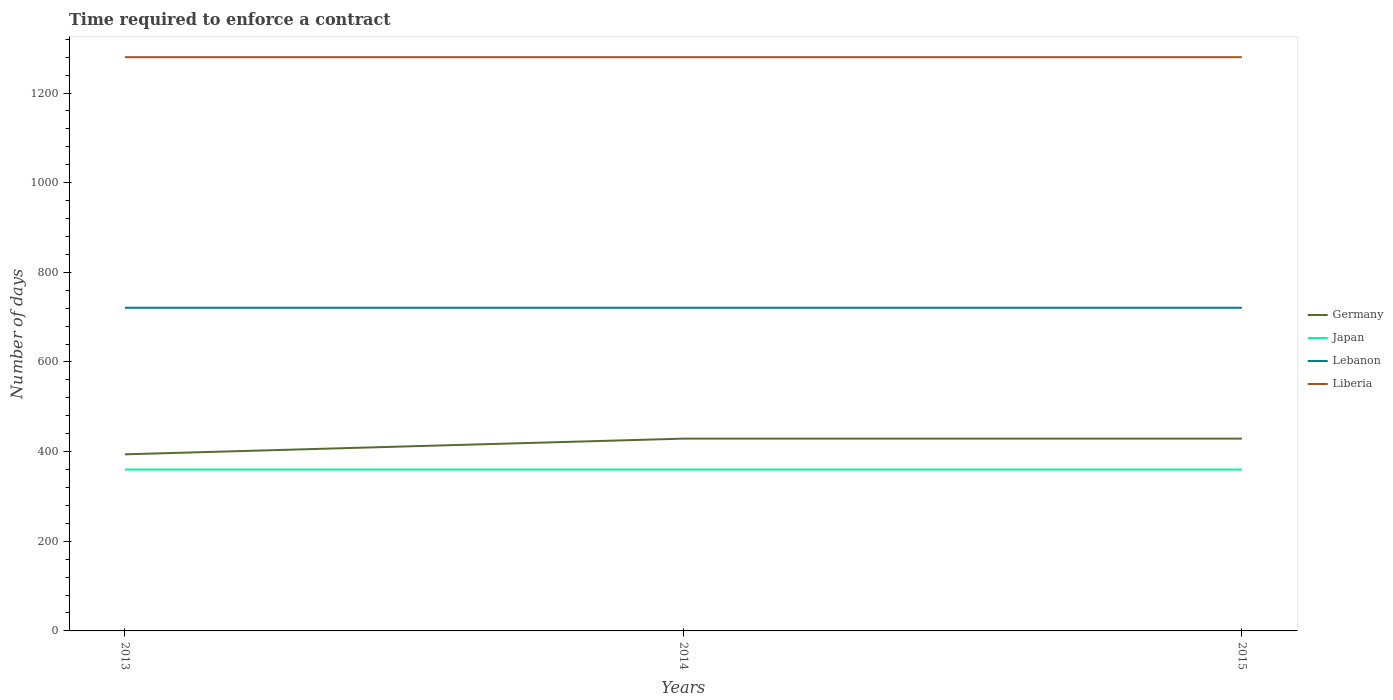How many different coloured lines are there?
Provide a short and direct response. 4. Does the line corresponding to Japan intersect with the line corresponding to Liberia?
Ensure brevity in your answer.  No. Across all years, what is the maximum number of days required to enforce a contract in Lebanon?
Provide a succinct answer. 721. What is the total number of days required to enforce a contract in Japan in the graph?
Give a very brief answer. 0. What is the difference between the highest and the second highest number of days required to enforce a contract in Lebanon?
Provide a short and direct response. 0. Is the number of days required to enforce a contract in Liberia strictly greater than the number of days required to enforce a contract in Germany over the years?
Provide a succinct answer. No. What is the difference between two consecutive major ticks on the Y-axis?
Your response must be concise. 200. How many legend labels are there?
Your answer should be compact. 4. What is the title of the graph?
Your response must be concise. Time required to enforce a contract. What is the label or title of the X-axis?
Ensure brevity in your answer.  Years. What is the label or title of the Y-axis?
Your answer should be compact. Number of days. What is the Number of days in Germany in 2013?
Your response must be concise. 394. What is the Number of days of Japan in 2013?
Offer a terse response. 360. What is the Number of days of Lebanon in 2013?
Make the answer very short. 721. What is the Number of days of Liberia in 2013?
Keep it short and to the point. 1280. What is the Number of days of Germany in 2014?
Your answer should be compact. 429. What is the Number of days in Japan in 2014?
Offer a very short reply. 360. What is the Number of days in Lebanon in 2014?
Your response must be concise. 721. What is the Number of days of Liberia in 2014?
Make the answer very short. 1280. What is the Number of days of Germany in 2015?
Offer a terse response. 429. What is the Number of days of Japan in 2015?
Provide a short and direct response. 360. What is the Number of days of Lebanon in 2015?
Your answer should be very brief. 721. What is the Number of days in Liberia in 2015?
Your response must be concise. 1280. Across all years, what is the maximum Number of days in Germany?
Make the answer very short. 429. Across all years, what is the maximum Number of days of Japan?
Your response must be concise. 360. Across all years, what is the maximum Number of days in Lebanon?
Offer a terse response. 721. Across all years, what is the maximum Number of days in Liberia?
Provide a short and direct response. 1280. Across all years, what is the minimum Number of days in Germany?
Provide a succinct answer. 394. Across all years, what is the minimum Number of days in Japan?
Your answer should be very brief. 360. Across all years, what is the minimum Number of days of Lebanon?
Provide a succinct answer. 721. Across all years, what is the minimum Number of days in Liberia?
Your response must be concise. 1280. What is the total Number of days of Germany in the graph?
Keep it short and to the point. 1252. What is the total Number of days in Japan in the graph?
Make the answer very short. 1080. What is the total Number of days in Lebanon in the graph?
Your response must be concise. 2163. What is the total Number of days in Liberia in the graph?
Offer a very short reply. 3840. What is the difference between the Number of days in Germany in 2013 and that in 2014?
Offer a terse response. -35. What is the difference between the Number of days in Lebanon in 2013 and that in 2014?
Your answer should be very brief. 0. What is the difference between the Number of days in Liberia in 2013 and that in 2014?
Offer a very short reply. 0. What is the difference between the Number of days of Germany in 2013 and that in 2015?
Offer a very short reply. -35. What is the difference between the Number of days of Germany in 2014 and that in 2015?
Make the answer very short. 0. What is the difference between the Number of days of Japan in 2014 and that in 2015?
Your answer should be compact. 0. What is the difference between the Number of days of Liberia in 2014 and that in 2015?
Provide a short and direct response. 0. What is the difference between the Number of days of Germany in 2013 and the Number of days of Lebanon in 2014?
Your response must be concise. -327. What is the difference between the Number of days of Germany in 2013 and the Number of days of Liberia in 2014?
Your answer should be very brief. -886. What is the difference between the Number of days of Japan in 2013 and the Number of days of Lebanon in 2014?
Give a very brief answer. -361. What is the difference between the Number of days in Japan in 2013 and the Number of days in Liberia in 2014?
Offer a very short reply. -920. What is the difference between the Number of days of Lebanon in 2013 and the Number of days of Liberia in 2014?
Ensure brevity in your answer.  -559. What is the difference between the Number of days in Germany in 2013 and the Number of days in Lebanon in 2015?
Give a very brief answer. -327. What is the difference between the Number of days of Germany in 2013 and the Number of days of Liberia in 2015?
Offer a terse response. -886. What is the difference between the Number of days in Japan in 2013 and the Number of days in Lebanon in 2015?
Provide a short and direct response. -361. What is the difference between the Number of days of Japan in 2013 and the Number of days of Liberia in 2015?
Give a very brief answer. -920. What is the difference between the Number of days in Lebanon in 2013 and the Number of days in Liberia in 2015?
Keep it short and to the point. -559. What is the difference between the Number of days in Germany in 2014 and the Number of days in Japan in 2015?
Provide a short and direct response. 69. What is the difference between the Number of days of Germany in 2014 and the Number of days of Lebanon in 2015?
Keep it short and to the point. -292. What is the difference between the Number of days in Germany in 2014 and the Number of days in Liberia in 2015?
Make the answer very short. -851. What is the difference between the Number of days of Japan in 2014 and the Number of days of Lebanon in 2015?
Offer a terse response. -361. What is the difference between the Number of days in Japan in 2014 and the Number of days in Liberia in 2015?
Ensure brevity in your answer.  -920. What is the difference between the Number of days in Lebanon in 2014 and the Number of days in Liberia in 2015?
Offer a very short reply. -559. What is the average Number of days in Germany per year?
Give a very brief answer. 417.33. What is the average Number of days of Japan per year?
Keep it short and to the point. 360. What is the average Number of days of Lebanon per year?
Offer a terse response. 721. What is the average Number of days of Liberia per year?
Make the answer very short. 1280. In the year 2013, what is the difference between the Number of days of Germany and Number of days of Lebanon?
Provide a succinct answer. -327. In the year 2013, what is the difference between the Number of days of Germany and Number of days of Liberia?
Keep it short and to the point. -886. In the year 2013, what is the difference between the Number of days of Japan and Number of days of Lebanon?
Offer a very short reply. -361. In the year 2013, what is the difference between the Number of days of Japan and Number of days of Liberia?
Give a very brief answer. -920. In the year 2013, what is the difference between the Number of days of Lebanon and Number of days of Liberia?
Your answer should be compact. -559. In the year 2014, what is the difference between the Number of days of Germany and Number of days of Lebanon?
Ensure brevity in your answer.  -292. In the year 2014, what is the difference between the Number of days of Germany and Number of days of Liberia?
Make the answer very short. -851. In the year 2014, what is the difference between the Number of days in Japan and Number of days in Lebanon?
Offer a very short reply. -361. In the year 2014, what is the difference between the Number of days in Japan and Number of days in Liberia?
Keep it short and to the point. -920. In the year 2014, what is the difference between the Number of days in Lebanon and Number of days in Liberia?
Your answer should be compact. -559. In the year 2015, what is the difference between the Number of days of Germany and Number of days of Japan?
Your answer should be compact. 69. In the year 2015, what is the difference between the Number of days of Germany and Number of days of Lebanon?
Make the answer very short. -292. In the year 2015, what is the difference between the Number of days of Germany and Number of days of Liberia?
Make the answer very short. -851. In the year 2015, what is the difference between the Number of days in Japan and Number of days in Lebanon?
Provide a short and direct response. -361. In the year 2015, what is the difference between the Number of days of Japan and Number of days of Liberia?
Your answer should be very brief. -920. In the year 2015, what is the difference between the Number of days of Lebanon and Number of days of Liberia?
Your answer should be compact. -559. What is the ratio of the Number of days in Germany in 2013 to that in 2014?
Give a very brief answer. 0.92. What is the ratio of the Number of days of Germany in 2013 to that in 2015?
Provide a succinct answer. 0.92. What is the ratio of the Number of days in Japan in 2013 to that in 2015?
Make the answer very short. 1. What is the ratio of the Number of days in Lebanon in 2013 to that in 2015?
Offer a terse response. 1. What is the ratio of the Number of days of Liberia in 2013 to that in 2015?
Offer a terse response. 1. What is the ratio of the Number of days of Japan in 2014 to that in 2015?
Ensure brevity in your answer.  1. What is the ratio of the Number of days of Lebanon in 2014 to that in 2015?
Offer a very short reply. 1. What is the difference between the highest and the second highest Number of days in Lebanon?
Keep it short and to the point. 0. What is the difference between the highest and the second highest Number of days in Liberia?
Offer a terse response. 0. What is the difference between the highest and the lowest Number of days of Germany?
Provide a succinct answer. 35. What is the difference between the highest and the lowest Number of days of Lebanon?
Offer a very short reply. 0. 